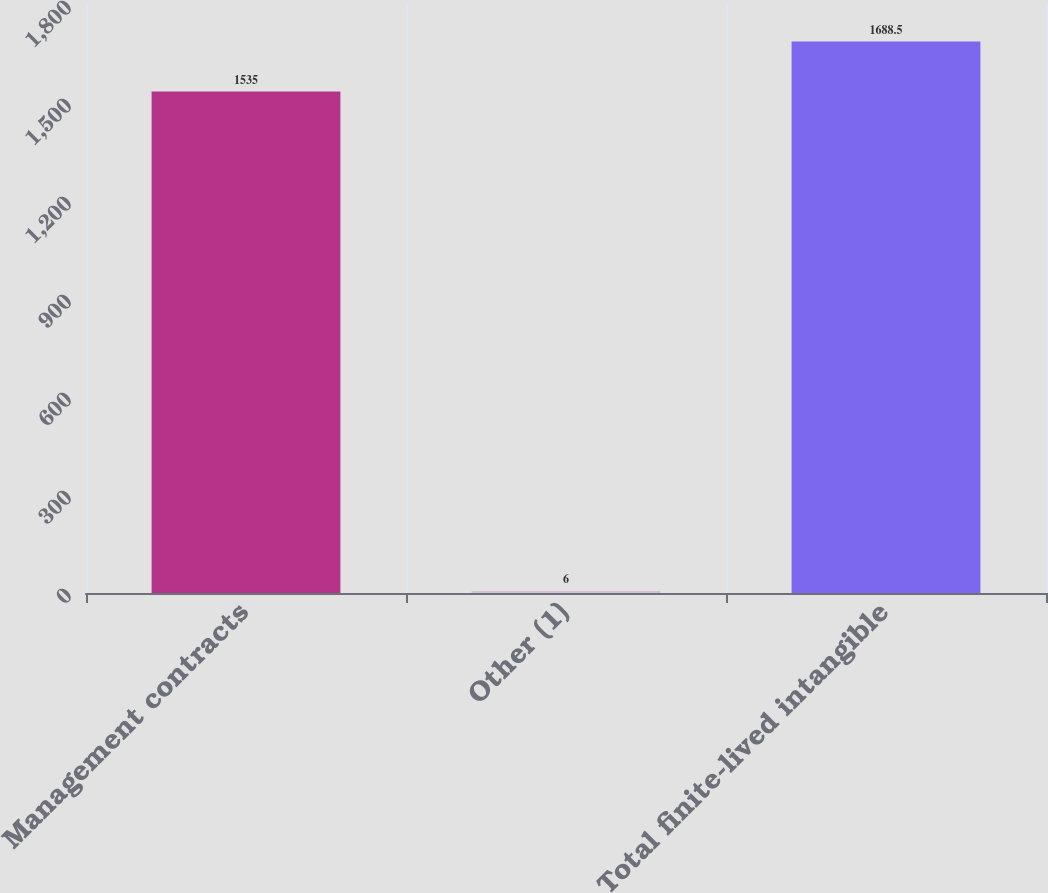Convert chart. <chart><loc_0><loc_0><loc_500><loc_500><bar_chart><fcel>Management contracts<fcel>Other (1)<fcel>Total finite-lived intangible<nl><fcel>1535<fcel>6<fcel>1688.5<nl></chart> 